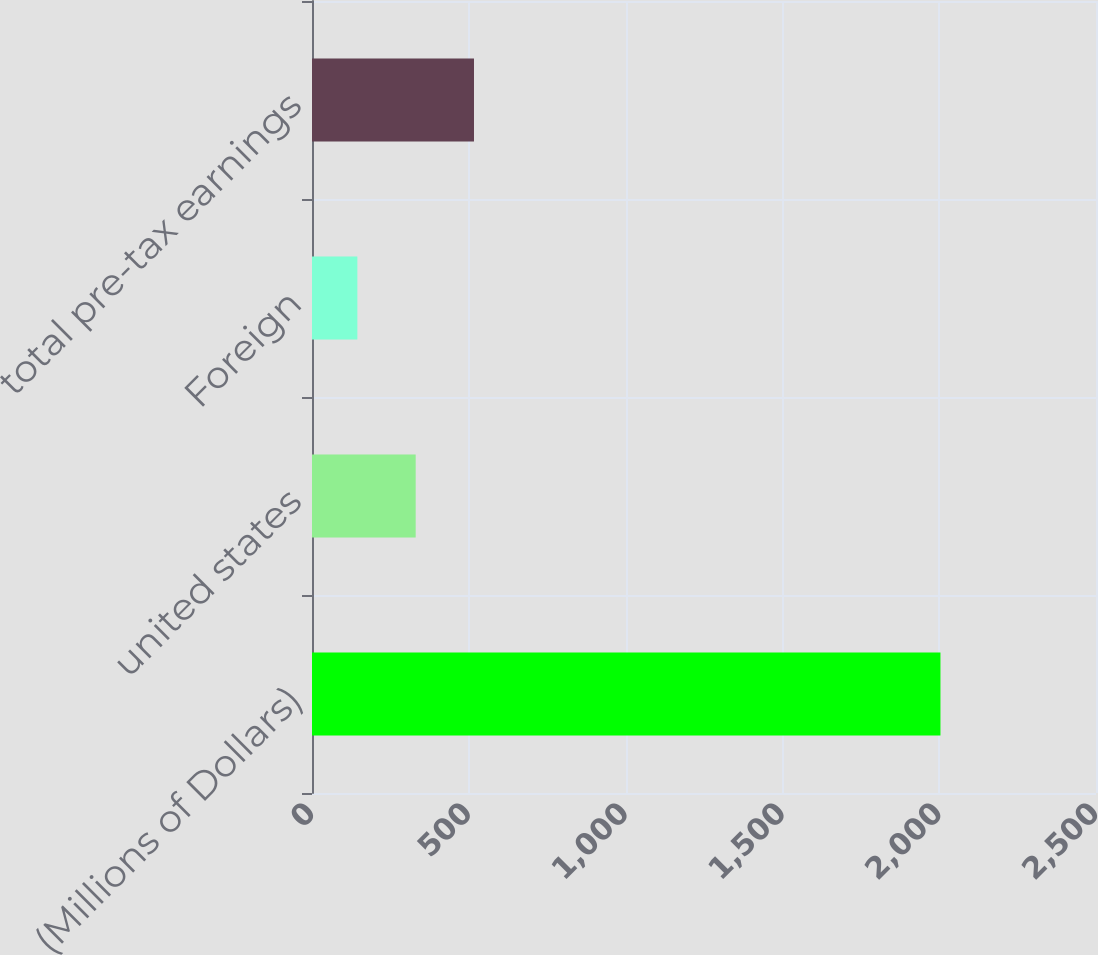<chart> <loc_0><loc_0><loc_500><loc_500><bar_chart><fcel>(Millions of Dollars)<fcel>united states<fcel>Foreign<fcel>total pre-tax earnings<nl><fcel>2004<fcel>330.63<fcel>144.7<fcel>516.56<nl></chart> 